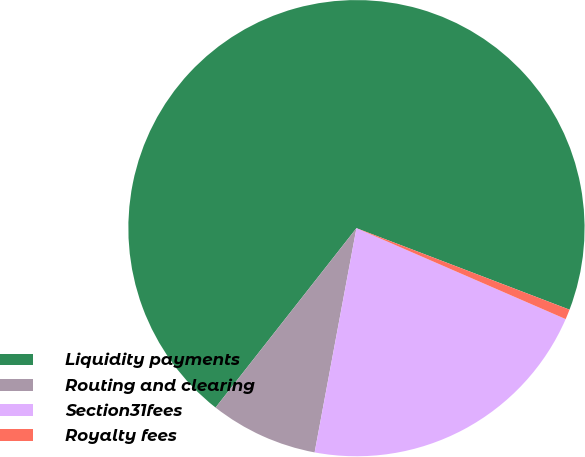<chart> <loc_0><loc_0><loc_500><loc_500><pie_chart><fcel>Liquidity payments<fcel>Routing and clearing<fcel>Section31fees<fcel>Royalty fees<nl><fcel>70.22%<fcel>7.66%<fcel>21.41%<fcel>0.71%<nl></chart> 